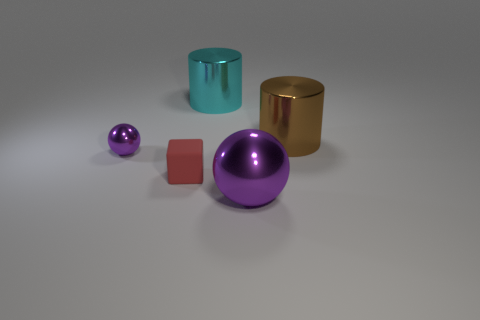Is the number of purple things to the left of the red matte thing greater than the number of large brown objects that are behind the cyan metal object?
Your response must be concise. Yes. Does the purple ball that is to the right of the matte cube have the same material as the small object that is left of the block?
Ensure brevity in your answer.  Yes. Are there any large purple metal balls left of the tiny matte cube?
Ensure brevity in your answer.  No. What number of green things are either big metallic things or big cylinders?
Provide a succinct answer. 0. Is the large brown object made of the same material as the sphere behind the big purple metallic sphere?
Provide a short and direct response. Yes. The other purple metal object that is the same shape as the large purple metal object is what size?
Provide a succinct answer. Small. What material is the tiny block?
Make the answer very short. Rubber. What material is the purple ball left of the purple shiny ball that is on the right side of the tiny object that is left of the tiny rubber thing?
Give a very brief answer. Metal. There is a shiny cylinder to the left of the brown metallic cylinder; does it have the same size as the metallic ball left of the tiny red matte cube?
Your response must be concise. No. What number of other things are there of the same material as the small cube
Provide a short and direct response. 0. 